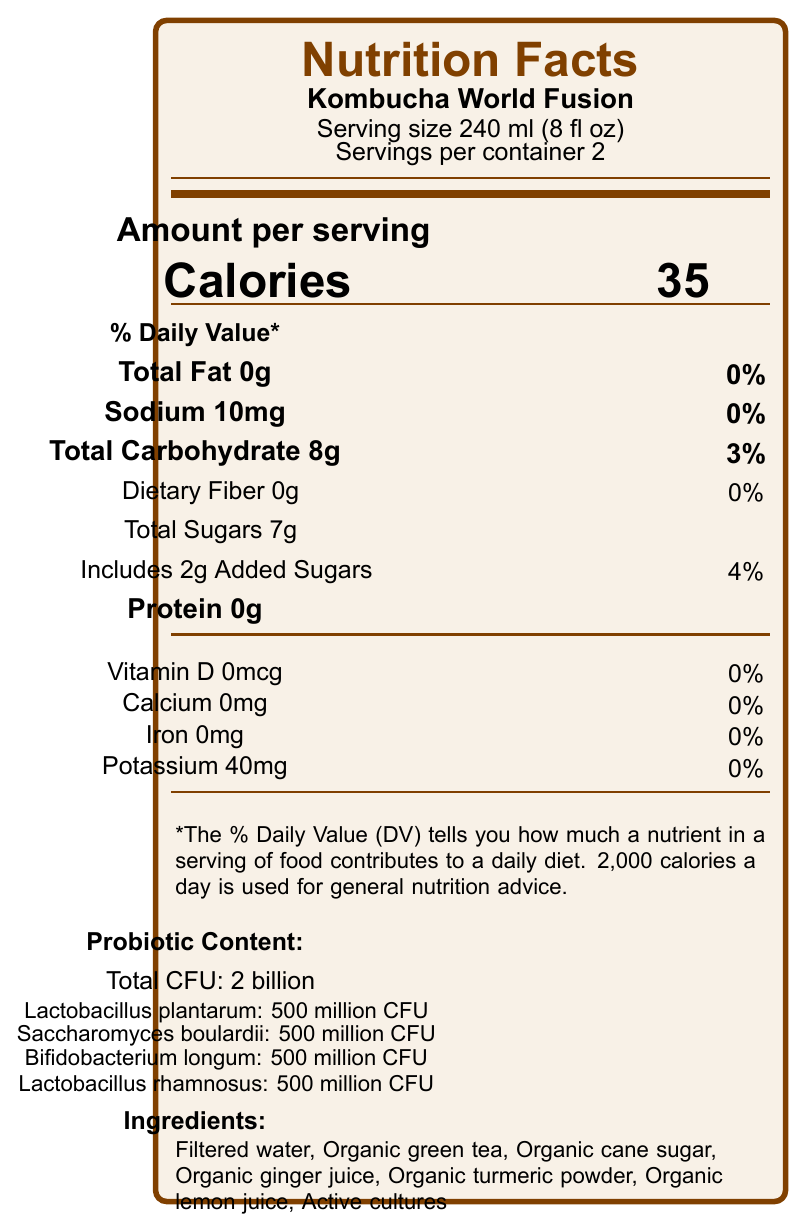What is the serving size for Kombucha World Fusion? The serving size is listed as 240 ml (8 fl oz) directly under the product name.
Answer: 240 ml (8 fl oz) How many calories are there per serving? The calories per serving are listed prominently as 35.
Answer: 35 What is the percentage of daily value for sodium? The sodium daily value percentage is 0%, as noted next to the amount of sodium.
Answer: 0% What are the total sugars per serving? The total sugars per serving amount to 7 grams, as indicated under "Total Carbohydrate".
Answer: 7g What is the total CFU for the probiotic content? The total CFU for probiotic content is stated as 2 billion.
Answer: 2 billion Which probiotic strain is not included in Kombucha World Fusion? A. Lactobacillus plantarum B. Saccharomyces boulardii C. Bifidobacterium longum D. Lactobacillus reuteri Lactobacillus reuteri is not listed among the probiotic strains; only Lactobacillus plantarum, Saccharomyces boulardii, Bifidobacterium longum, and Lactobacillus rhamnosus are included.
Answer: D How much added sugar is in each serving? The amount of added sugar per serving is 2 grams.
Answer: 2g Does Kombucha World Fusion contain any protein? The nutrition facts clearly state that there is 0 grams of protein per serving.
Answer: No What is the main flavor profile of Kombucha World Fusion? The flavor profile is described as tangy, slightly sweet with notes of ginger, turmeric, and citrus.
Answer: Tangy, slightly sweet with notes of ginger, turmeric, and citrus Which of the following dishes is recommended to pair with Kombucha World Fusion? A. Italian spaghetti B. Thai green curry C. French croissant Thai green curry is one of the recommended pairings listed, while the others are not mentioned.
Answer: B Is Kombucha World Fusion's packaging sustainable? The document mentions that the packaging is made from 100% recycled materials.
Answer: Yes Summarize the key nutritional and probiotic content of Kombucha World Fusion. This summary covers the main nutritional facts, including caloric content, macro and micro-nutrient details, and probiotic information, providing a complete overview.
Answer: Kombucha World Fusion has 35 calories per serving, 0g total fat, 10mg sodium (0% DV), 8g total carbohydrates (3% DV) including 7g total sugars and 2g added sugars, and 0g protein. It contains probiotics with a total CFU of 2 billion, including strains such as Lactobacillus plantarum, Saccharomyces boulardii, Bifidobacterium longum, and Lactobacillus rhamnosus. What traditional food cultures inspired Kombucha World Fusion? The cultural inspiration is mentioned as traditional fermented beverages from Asia, Africa, and South America.
Answer: Asia, Africa, and South America What is the amount of potassium per serving, and what percentage of the daily value does this correspond to? Each serving contains 40mg of potassium, which corresponds to 0% of the daily value.
Answer: 40mg, 0% What are the health claims associated with Kombucha World Fusion? These health claims are directly listed in the document.
Answer: May support digestive health, Contains live and active cultures, No artificial colors or preservatives Can the exact amount of organic ginger juice in the ingredients be found in the document? The document lists organic ginger juice as an ingredient but does not specify the exact amount.
Answer: No 